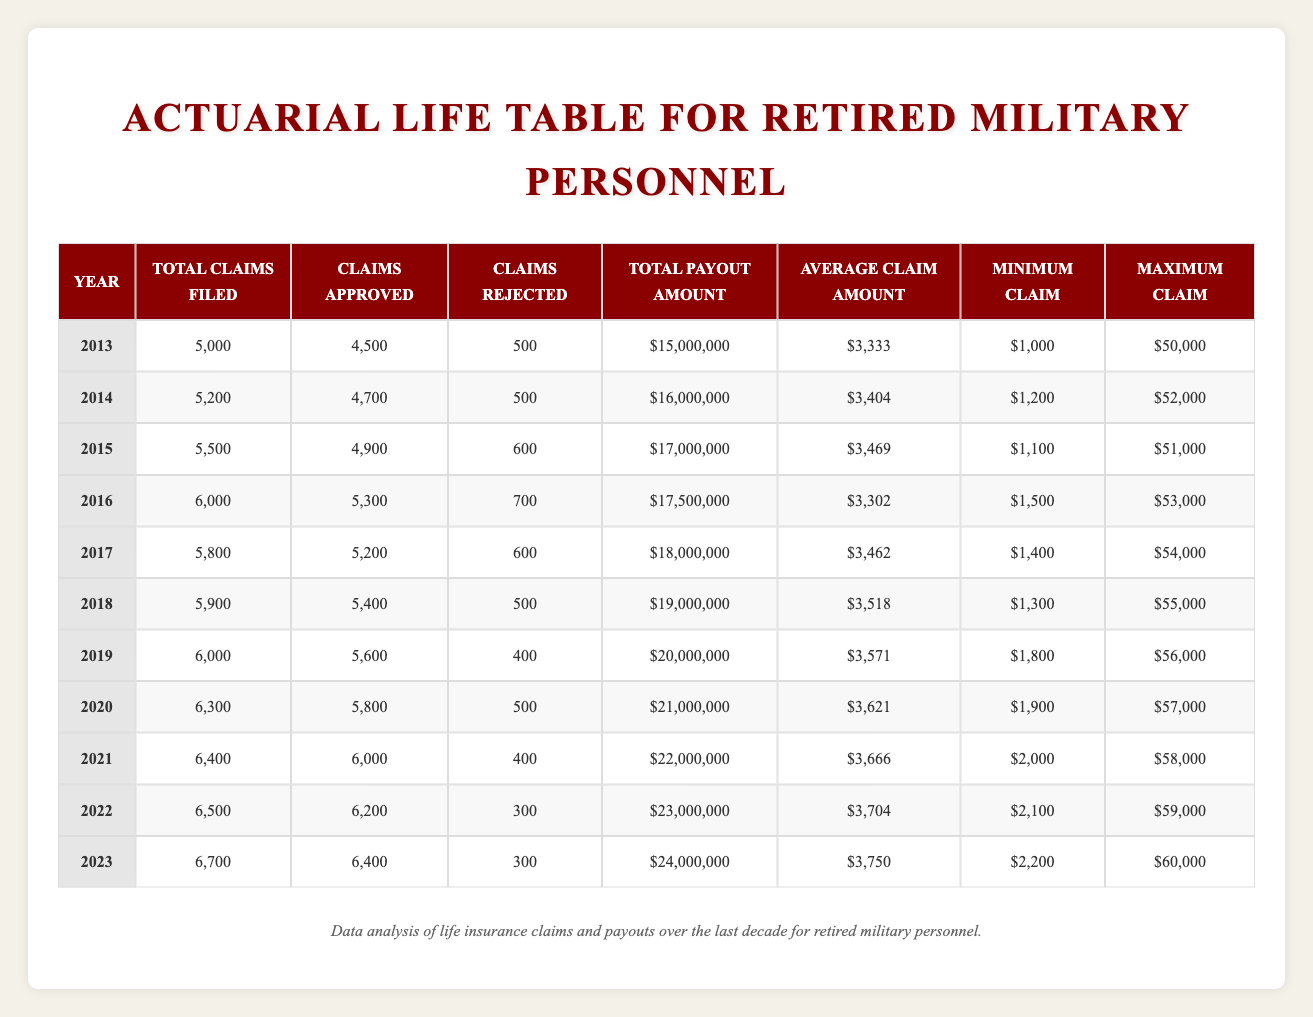What year had the highest total claims filed? Looking at the total claims filed each year, we can see that 2023 has the highest value with 6,700 claims filed.
Answer: 2023 What was the average claim amount in 2020? The average claim amount in 2020 is directly listed in the table as $3,621.
Answer: $3,621 How many claims were rejected in 2019? According to the table, in 2019, the number of claims rejected is shown as 400.
Answer: 400 What is the total payout amount for the years 2013 to 2015? The total payout amounts for 2013, 2014, and 2015 are $15,000,000, $16,000,000, and $17,000,000 respectively. Adding these amounts gives us $15,000,000 + $16,000,000 + $17,000,000 = $48,000,000.
Answer: $48,000,000 Was the average claim amount higher in 2022 compared to 2021? The average claim amount in 2022 is $3,704 and in 2021 is $3,666. Since $3,704 is greater than $3,666, we conclude that the average claim amount was higher in 2022.
Answer: Yes What is the difference between the total claims filed in 2023 and 2017? For 2023, total claims filed is 6,700 and for 2017, it is 5,800. Calculating the difference, we find 6,700 - 5,800 = 900.
Answer: 900 What was the minimum claim amount across all years? The minimum claim amounts provided in the table are 1,000 (2013), 1,200 (2014), 1,100 (2015), 1,500 (2016), 1,400 (2017), 1,300 (2018), 1,800 (2019), 1,900 (2020), 2,000 (2021), 2,100 (2022), and 2,200 (2023). The smallest of these is 1,000 in 2013.
Answer: 1,000 Which year saw the largest increase in total payout from the previous year? To identify the largest increase, we calculate the payouts for each consecutive year: 2014 - 2013 = $16,000,000 - $15,000,000 = $1,000,000; 2015 - 2014 = $17,000,000 - $16,000,000 = $1,000,000; 2016 - 2015 = $17,500,000 - $17,000,000 = $500,000; 2017 - 2016 = $18,000,000 - $17,500,000 = $500,000; 2018 - 2017 = $19,000,000 - $18,000,000 = $1,000,000; 2019 - 2018 = $20,000,000 - $19,000,000 = $1,000,000; 2020 - 2019 = $21,000,000 - $20,000,000 = $1,000,000; 2021 - 2020 = $22,000,000 - $21,000,000 = $1,000,000; 2022 - 2021 = $23,000,000 - $22,000,000 = $1,000,000; 2023 - 2022 = $24,000,000 - $23,000,000 = $1,000,000. The largest increase is $1,000,000, occurring in multiple years. However, it can be noted that the increase is consistent across all these years.
Answer: 2014, 2015, 2018, 2019, 2020, 2021, 2022, 2023 (multiple years) How many more claims were approved in 2023 compared to 2020? In 2023, there were 6,400 approved claims, and in 2020, there were 5,800 approved claims. The difference is 6,400 - 5,800 = 600.
Answer: 600 